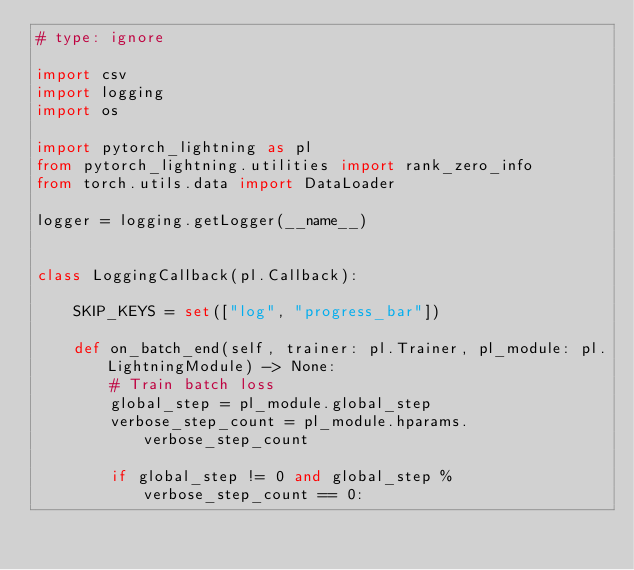Convert code to text. <code><loc_0><loc_0><loc_500><loc_500><_Python_># type: ignore

import csv
import logging
import os

import pytorch_lightning as pl
from pytorch_lightning.utilities import rank_zero_info
from torch.utils.data import DataLoader

logger = logging.getLogger(__name__)


class LoggingCallback(pl.Callback):

    SKIP_KEYS = set(["log", "progress_bar"])

    def on_batch_end(self, trainer: pl.Trainer, pl_module: pl.LightningModule) -> None:
        # Train batch loss
        global_step = pl_module.global_step
        verbose_step_count = pl_module.hparams.verbose_step_count

        if global_step != 0 and global_step % verbose_step_count == 0:</code> 